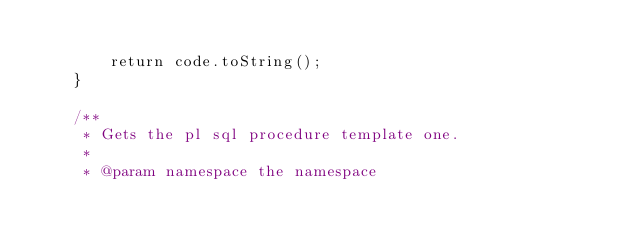Convert code to text. <code><loc_0><loc_0><loc_500><loc_500><_Java_>
        return code.toString();
    }

    /**
     * Gets the pl sql procedure template one.
     *
     * @param namespace the namespace</code> 